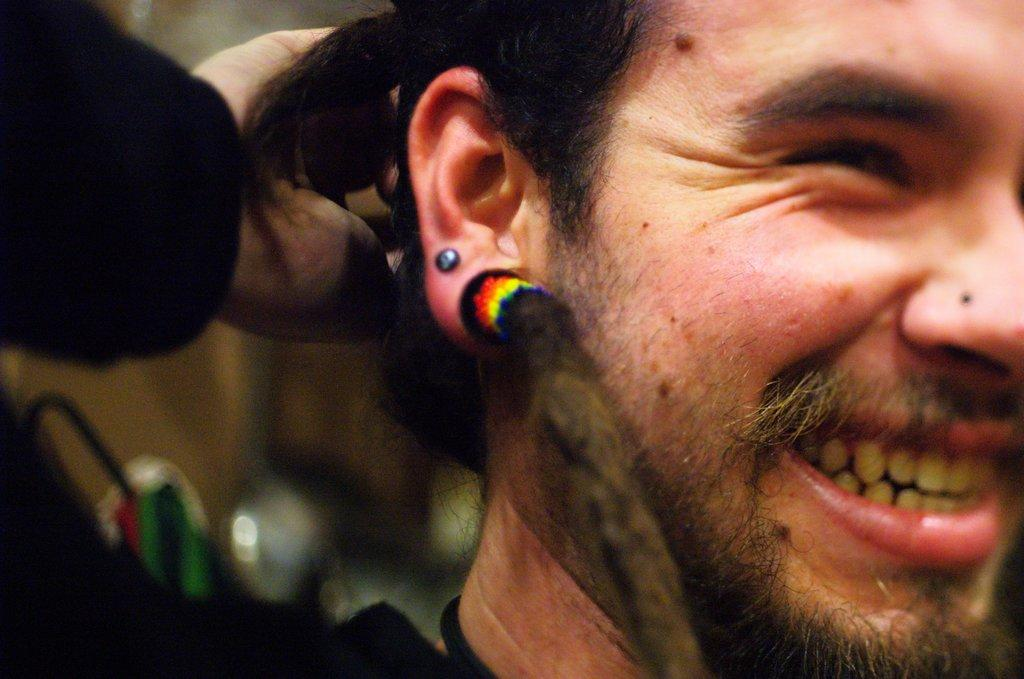Who or what is the main subject of the image? There is a person in the image. Can you describe the background of the image? The background of the image is blurred. How many children are playing volleyball on the desk in the image? There are no children, volleyball, or desk present in the image. 